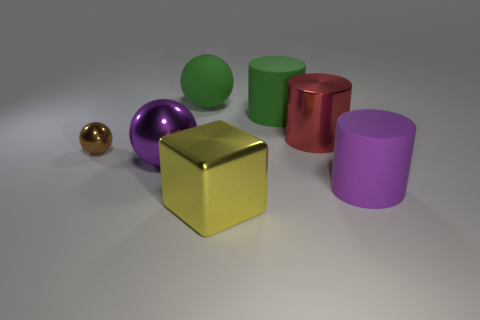What is the object that is to the left of the big cube and behind the small thing made of?
Your answer should be very brief. Rubber. Do the cylinder that is to the right of the shiny cylinder and the big green matte ball have the same size?
Provide a succinct answer. Yes. Are there any other things that are the same size as the yellow shiny object?
Your answer should be compact. Yes. Are there more big things behind the yellow shiny cube than big green balls to the left of the big green sphere?
Provide a short and direct response. Yes. There is a big sphere to the right of the purple thing to the left of the rubber cylinder on the left side of the red shiny object; what color is it?
Ensure brevity in your answer.  Green. Is the color of the big metal thing left of the metallic cube the same as the large metal block?
Offer a terse response. No. How many other things are there of the same color as the tiny metal object?
Provide a succinct answer. 0. How many things are either cyan matte cylinders or small brown metal objects?
Ensure brevity in your answer.  1. What number of things are purple shiny spheres or things that are right of the yellow object?
Ensure brevity in your answer.  4. Is the material of the brown object the same as the purple ball?
Offer a terse response. Yes. 